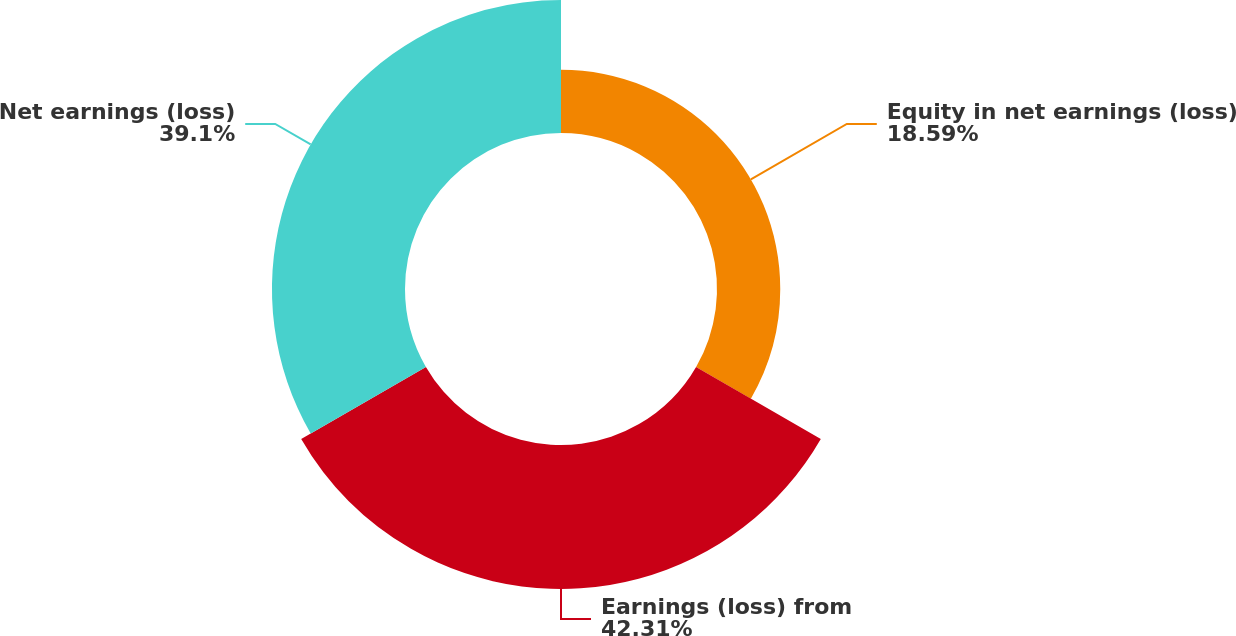Convert chart. <chart><loc_0><loc_0><loc_500><loc_500><pie_chart><fcel>Equity in net earnings (loss)<fcel>Earnings (loss) from<fcel>Net earnings (loss)<nl><fcel>18.59%<fcel>42.32%<fcel>39.1%<nl></chart> 